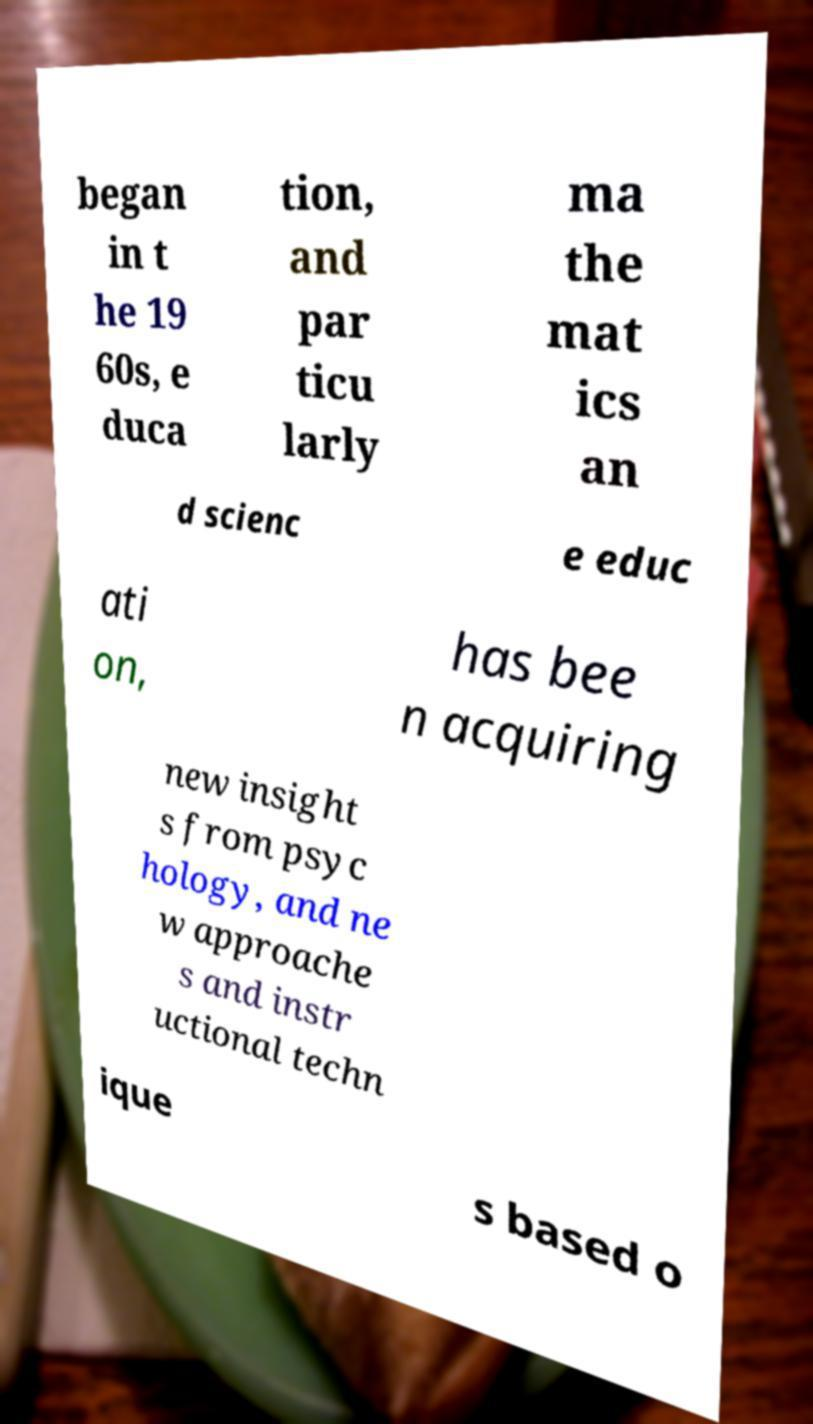Can you read and provide the text displayed in the image?This photo seems to have some interesting text. Can you extract and type it out for me? began in t he 19 60s, e duca tion, and par ticu larly ma the mat ics an d scienc e educ ati on, has bee n acquiring new insight s from psyc hology, and ne w approache s and instr uctional techn ique s based o 